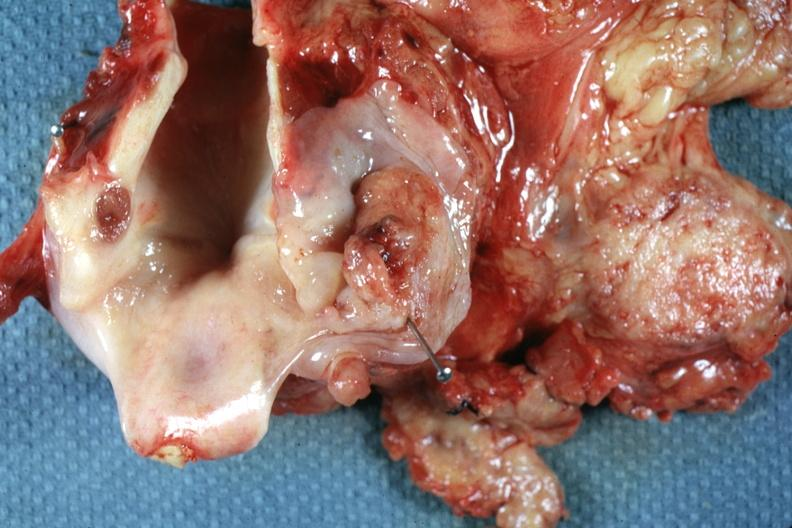where is this?
Answer the question using a single word or phrase. Oral 